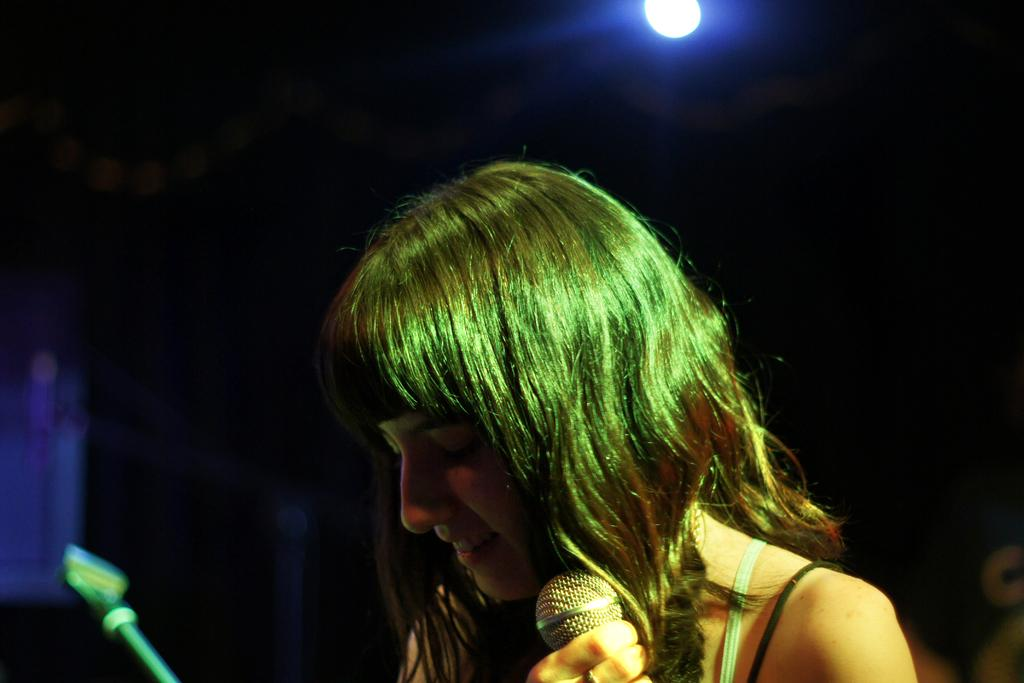Who is present in the image? There is a woman in the image. What object is visible in the image that is typically used for amplifying sound? There is a microphone in the image. What can be seen in the background of the image? There is light visible in the background of the image. What type of quince is being used as a prop in the image? There is no quince present in the image. What event is being celebrated in the image? The image does not depict a specific event or celebration. 